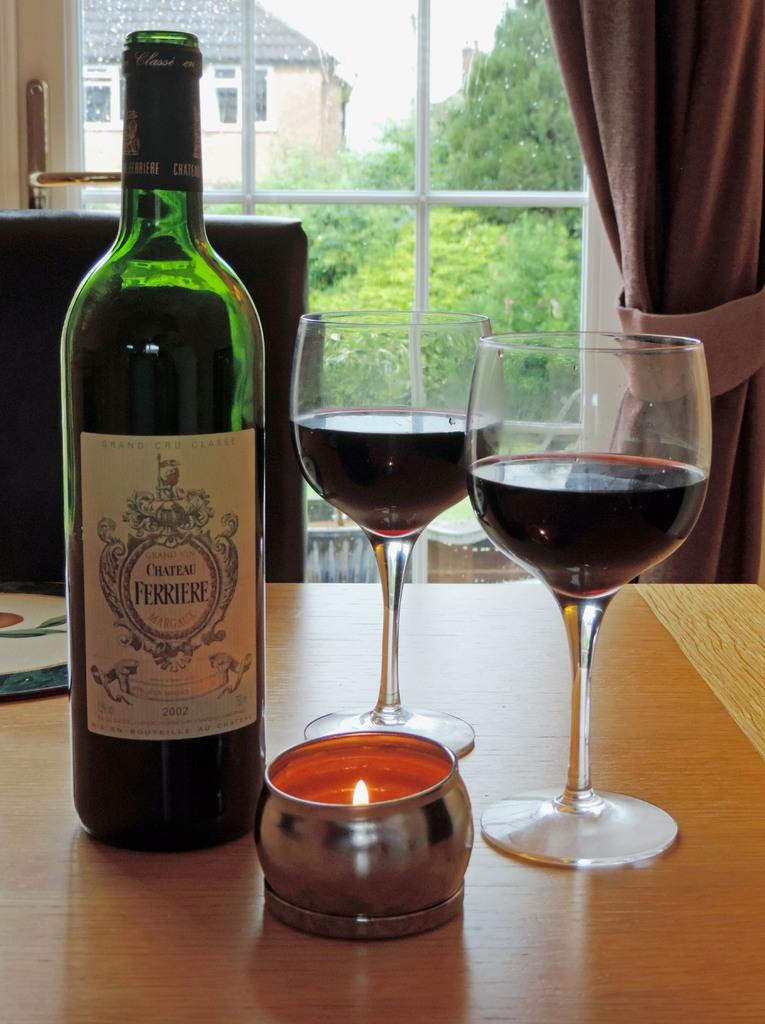Provide a one-sentence caption for the provided image. A candle, two glasses of wine and a bottle with a label saying "Chateau Ferriere". 